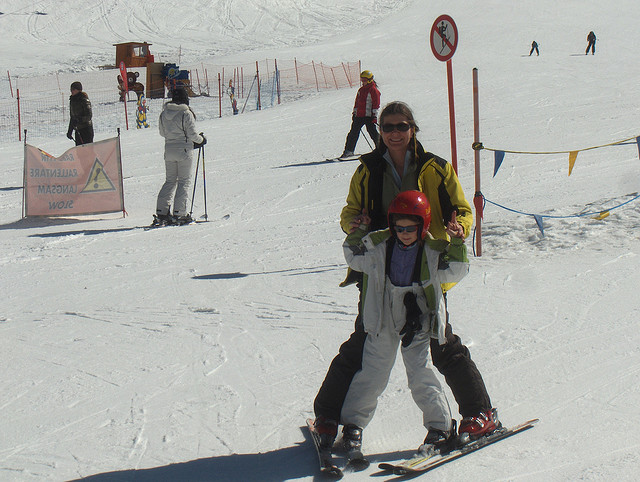Identify the text displayed in this image. WOR 